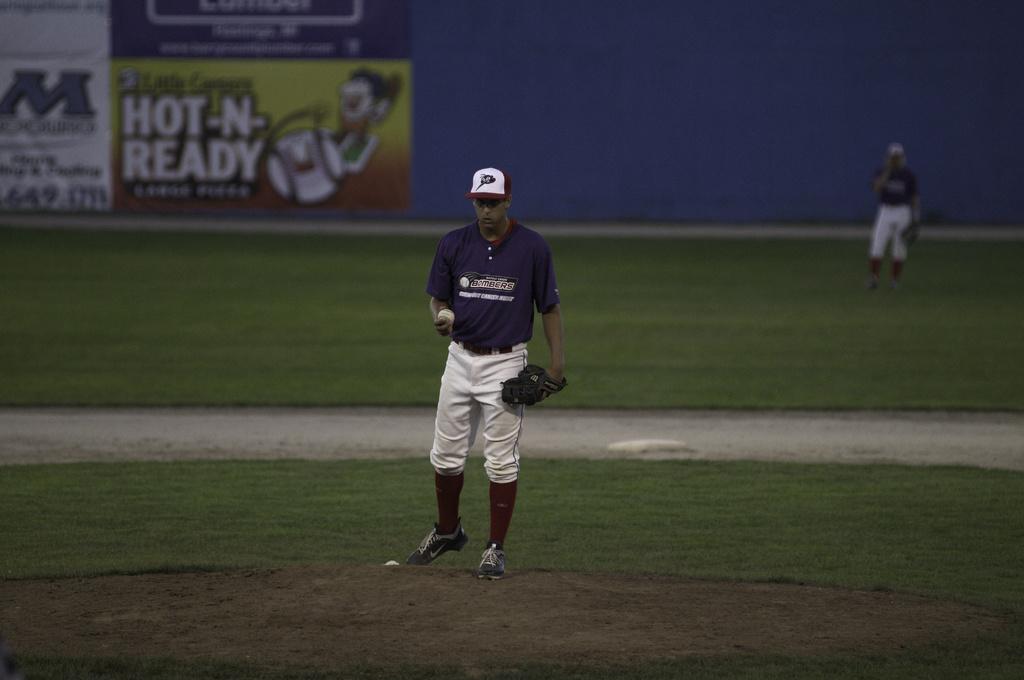What company's slogan is hot-n-ready?
Offer a terse response. Little caesars. Is that a giant letter "m" to the left?
Your response must be concise. Yes. 